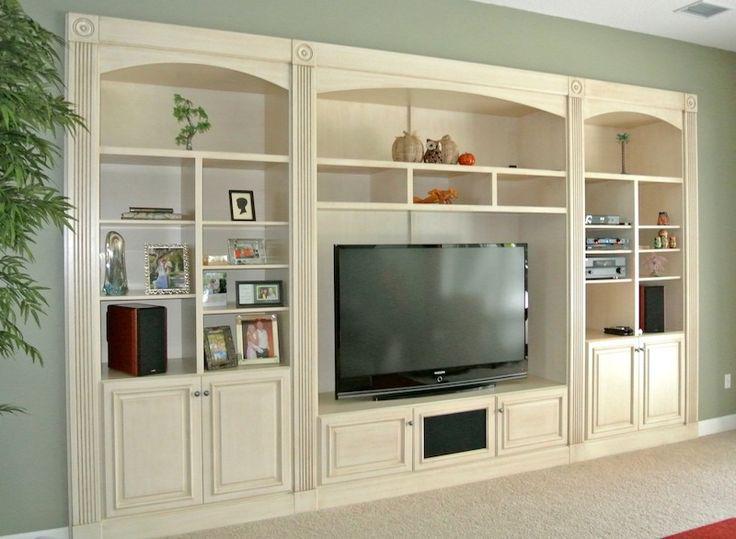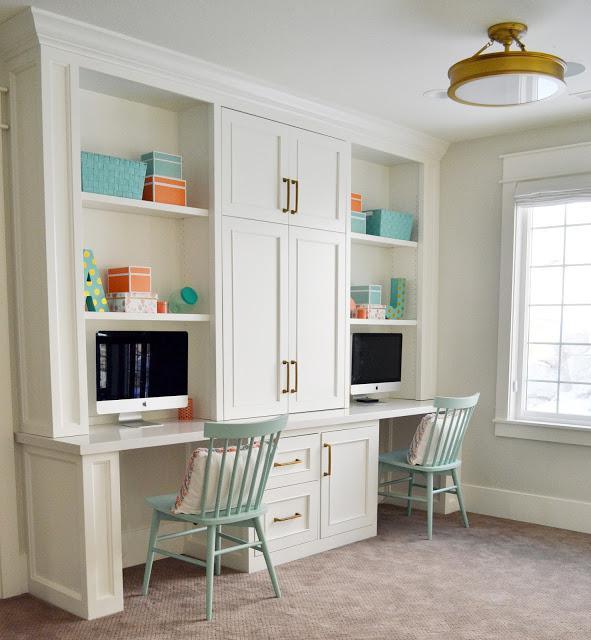The first image is the image on the left, the second image is the image on the right. Assess this claim about the two images: "At least two woode chairs are by a computer desk.". Correct or not? Answer yes or no. Yes. The first image is the image on the left, the second image is the image on the right. Considering the images on both sides, is "An image shows a desk topped with a monitor and coupled with brown shelves for books." valid? Answer yes or no. No. 